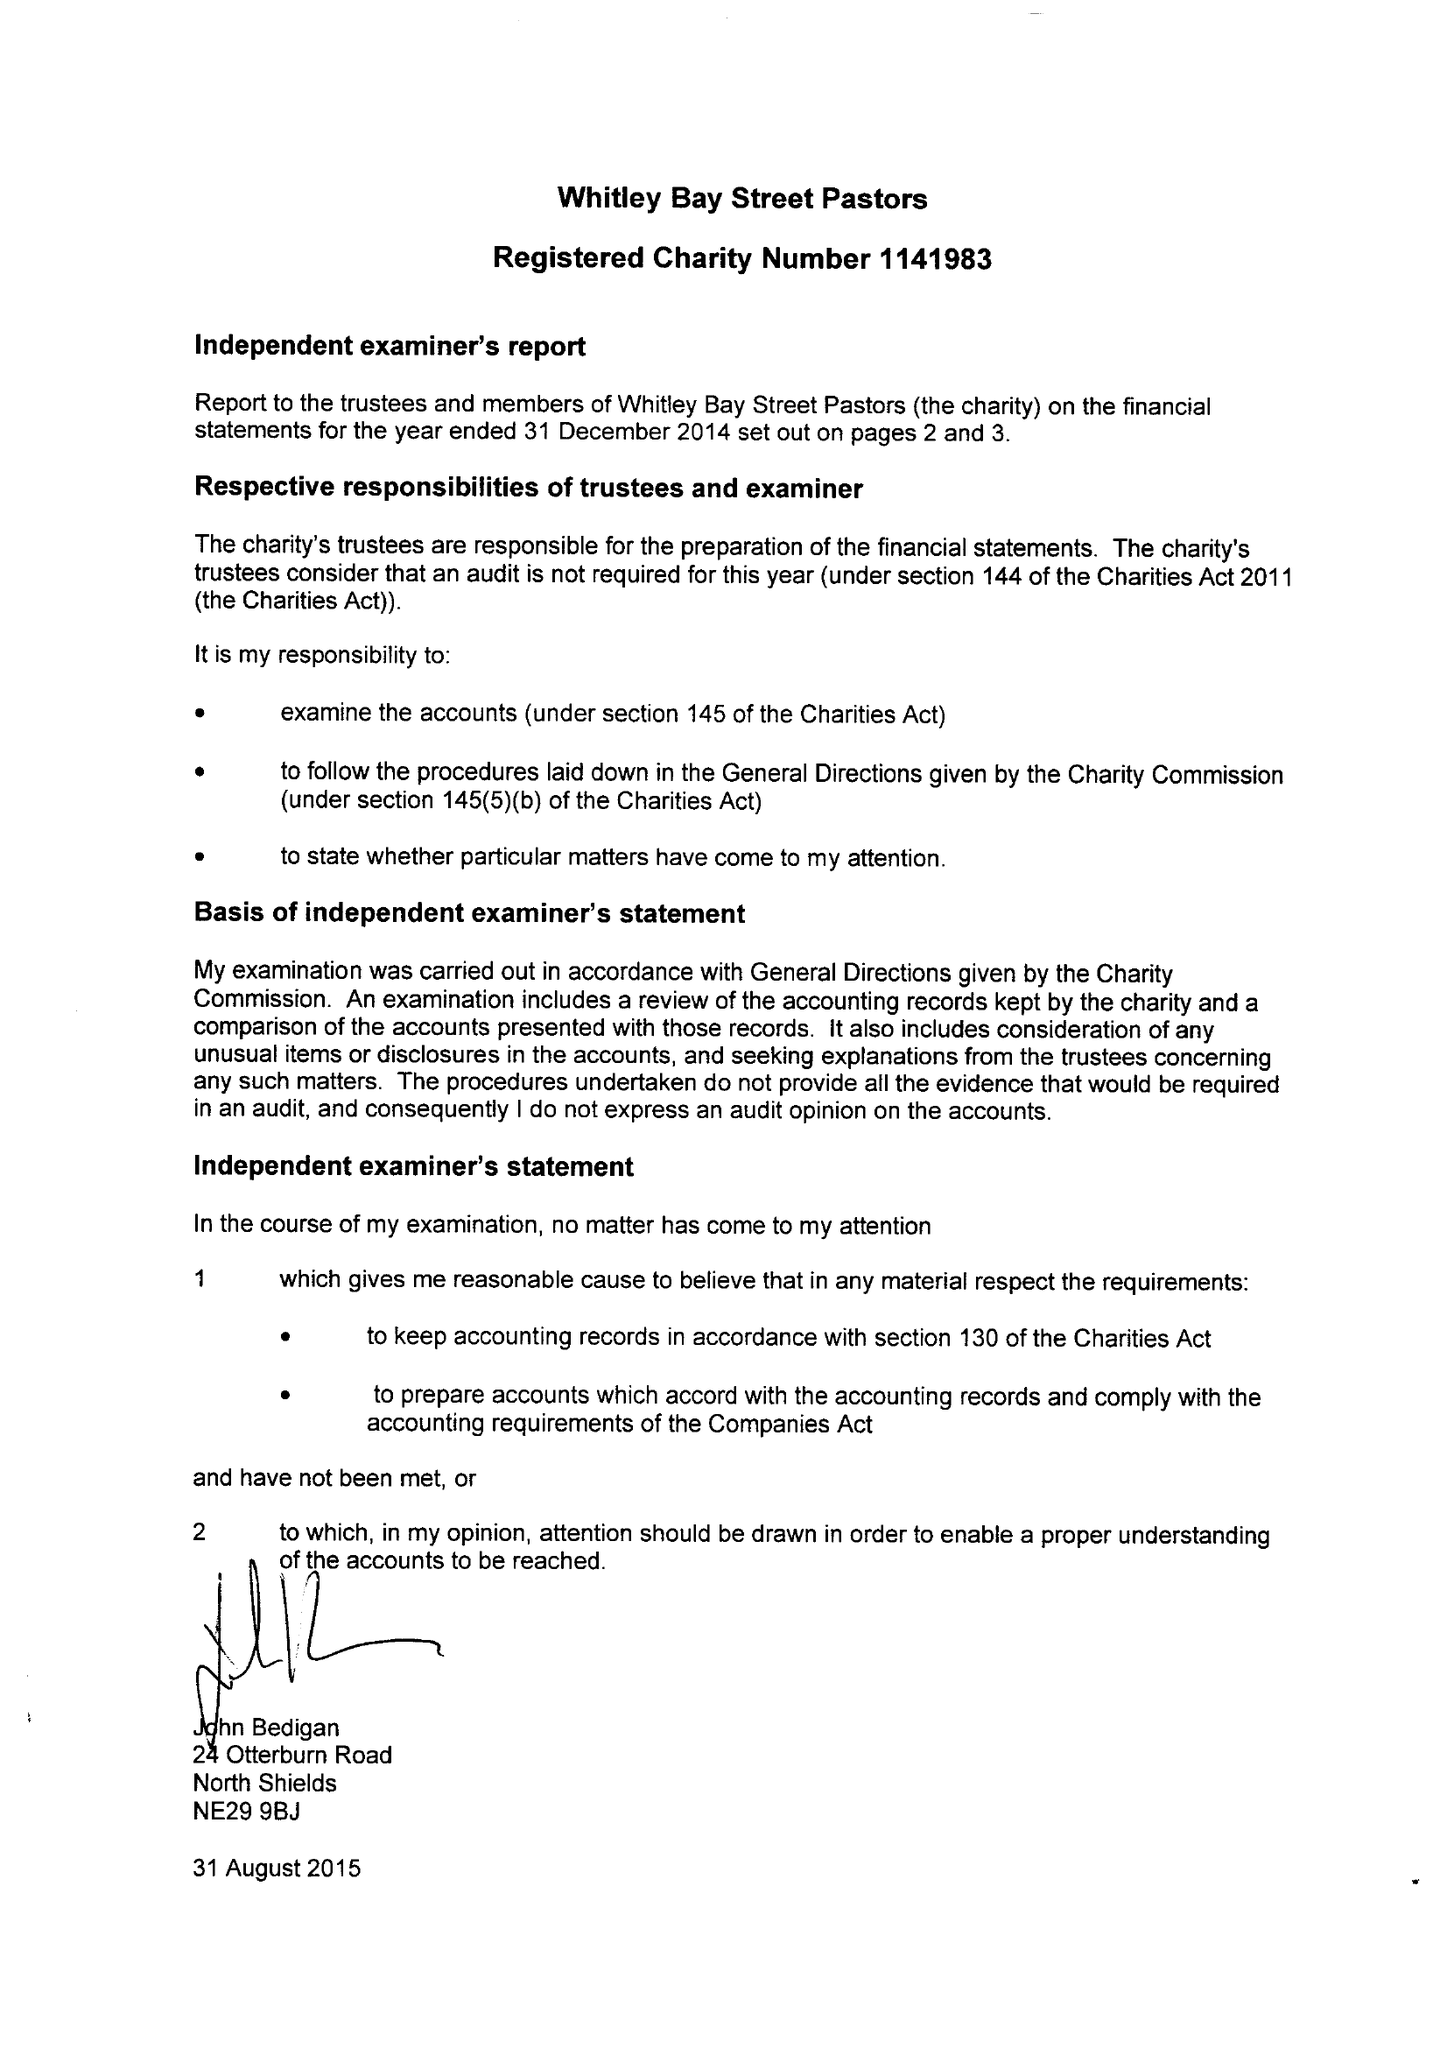What is the value for the address__street_line?
Answer the question using a single word or phrase. 109 WHITLEY ROAD 